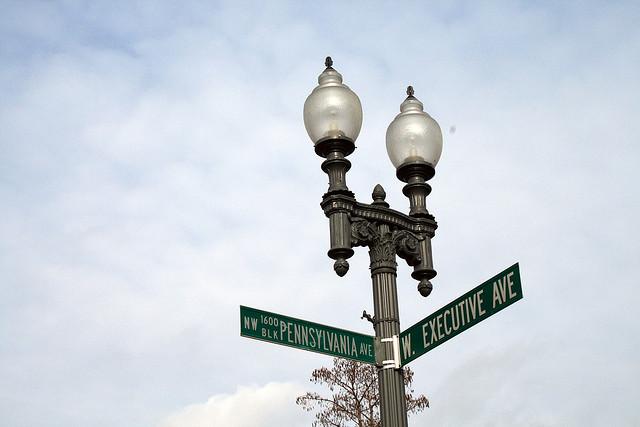How many light bulbs are there?
Keep it brief. 2. What color are the street signs?
Write a very short answer. Green. Is the sky clear?
Short answer required. No. 